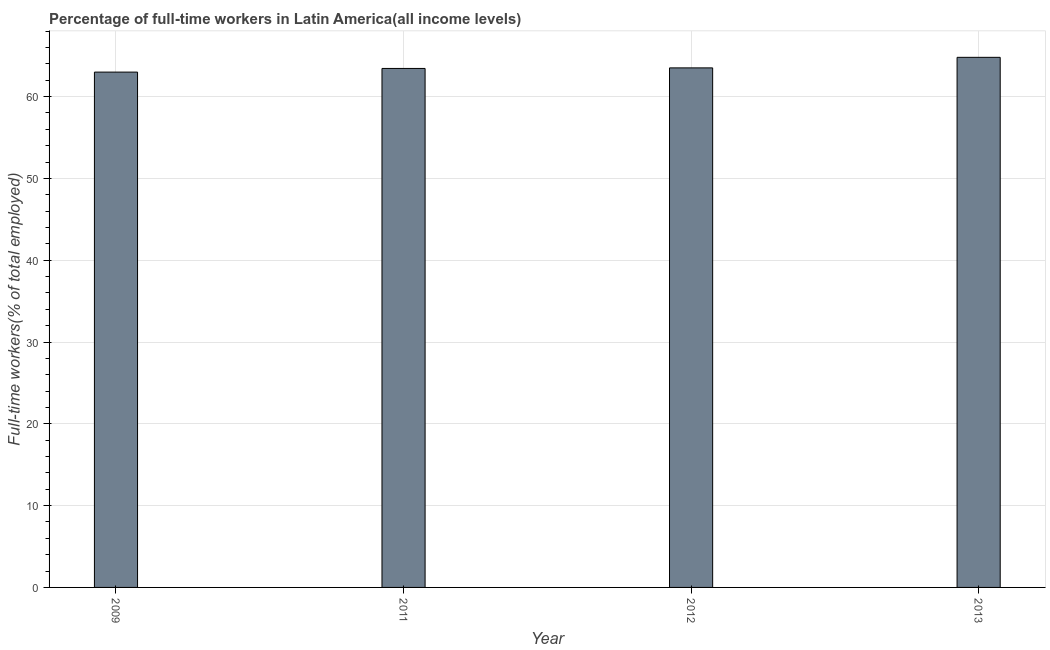Does the graph contain any zero values?
Offer a terse response. No. What is the title of the graph?
Provide a succinct answer. Percentage of full-time workers in Latin America(all income levels). What is the label or title of the X-axis?
Ensure brevity in your answer.  Year. What is the label or title of the Y-axis?
Provide a succinct answer. Full-time workers(% of total employed). What is the percentage of full-time workers in 2011?
Provide a succinct answer. 63.44. Across all years, what is the maximum percentage of full-time workers?
Keep it short and to the point. 64.8. Across all years, what is the minimum percentage of full-time workers?
Your answer should be compact. 62.99. In which year was the percentage of full-time workers maximum?
Your answer should be compact. 2013. What is the sum of the percentage of full-time workers?
Your answer should be compact. 254.74. What is the difference between the percentage of full-time workers in 2009 and 2011?
Offer a terse response. -0.45. What is the average percentage of full-time workers per year?
Provide a succinct answer. 63.69. What is the median percentage of full-time workers?
Your answer should be compact. 63.48. What is the ratio of the percentage of full-time workers in 2009 to that in 2013?
Keep it short and to the point. 0.97. Is the percentage of full-time workers in 2009 less than that in 2011?
Offer a very short reply. Yes. Is the difference between the percentage of full-time workers in 2009 and 2011 greater than the difference between any two years?
Your answer should be very brief. No. What is the difference between the highest and the second highest percentage of full-time workers?
Your answer should be compact. 1.29. What is the difference between the highest and the lowest percentage of full-time workers?
Make the answer very short. 1.81. In how many years, is the percentage of full-time workers greater than the average percentage of full-time workers taken over all years?
Give a very brief answer. 1. Are all the bars in the graph horizontal?
Your answer should be compact. No. What is the difference between two consecutive major ticks on the Y-axis?
Your answer should be compact. 10. Are the values on the major ticks of Y-axis written in scientific E-notation?
Your answer should be very brief. No. What is the Full-time workers(% of total employed) in 2009?
Your answer should be compact. 62.99. What is the Full-time workers(% of total employed) in 2011?
Ensure brevity in your answer.  63.44. What is the Full-time workers(% of total employed) in 2012?
Your answer should be very brief. 63.51. What is the Full-time workers(% of total employed) in 2013?
Your answer should be compact. 64.8. What is the difference between the Full-time workers(% of total employed) in 2009 and 2011?
Your answer should be very brief. -0.45. What is the difference between the Full-time workers(% of total employed) in 2009 and 2012?
Provide a short and direct response. -0.51. What is the difference between the Full-time workers(% of total employed) in 2009 and 2013?
Offer a very short reply. -1.81. What is the difference between the Full-time workers(% of total employed) in 2011 and 2012?
Provide a short and direct response. -0.07. What is the difference between the Full-time workers(% of total employed) in 2011 and 2013?
Make the answer very short. -1.36. What is the difference between the Full-time workers(% of total employed) in 2012 and 2013?
Make the answer very short. -1.29. What is the ratio of the Full-time workers(% of total employed) in 2009 to that in 2012?
Provide a succinct answer. 0.99. What is the ratio of the Full-time workers(% of total employed) in 2009 to that in 2013?
Offer a terse response. 0.97. 